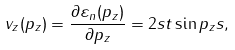Convert formula to latex. <formula><loc_0><loc_0><loc_500><loc_500>v _ { z } ( p _ { z } ) = \frac { \partial \varepsilon _ { n } ( p _ { z } ) } { \partial p _ { z } } = 2 s t \sin p _ { z } s ,</formula> 